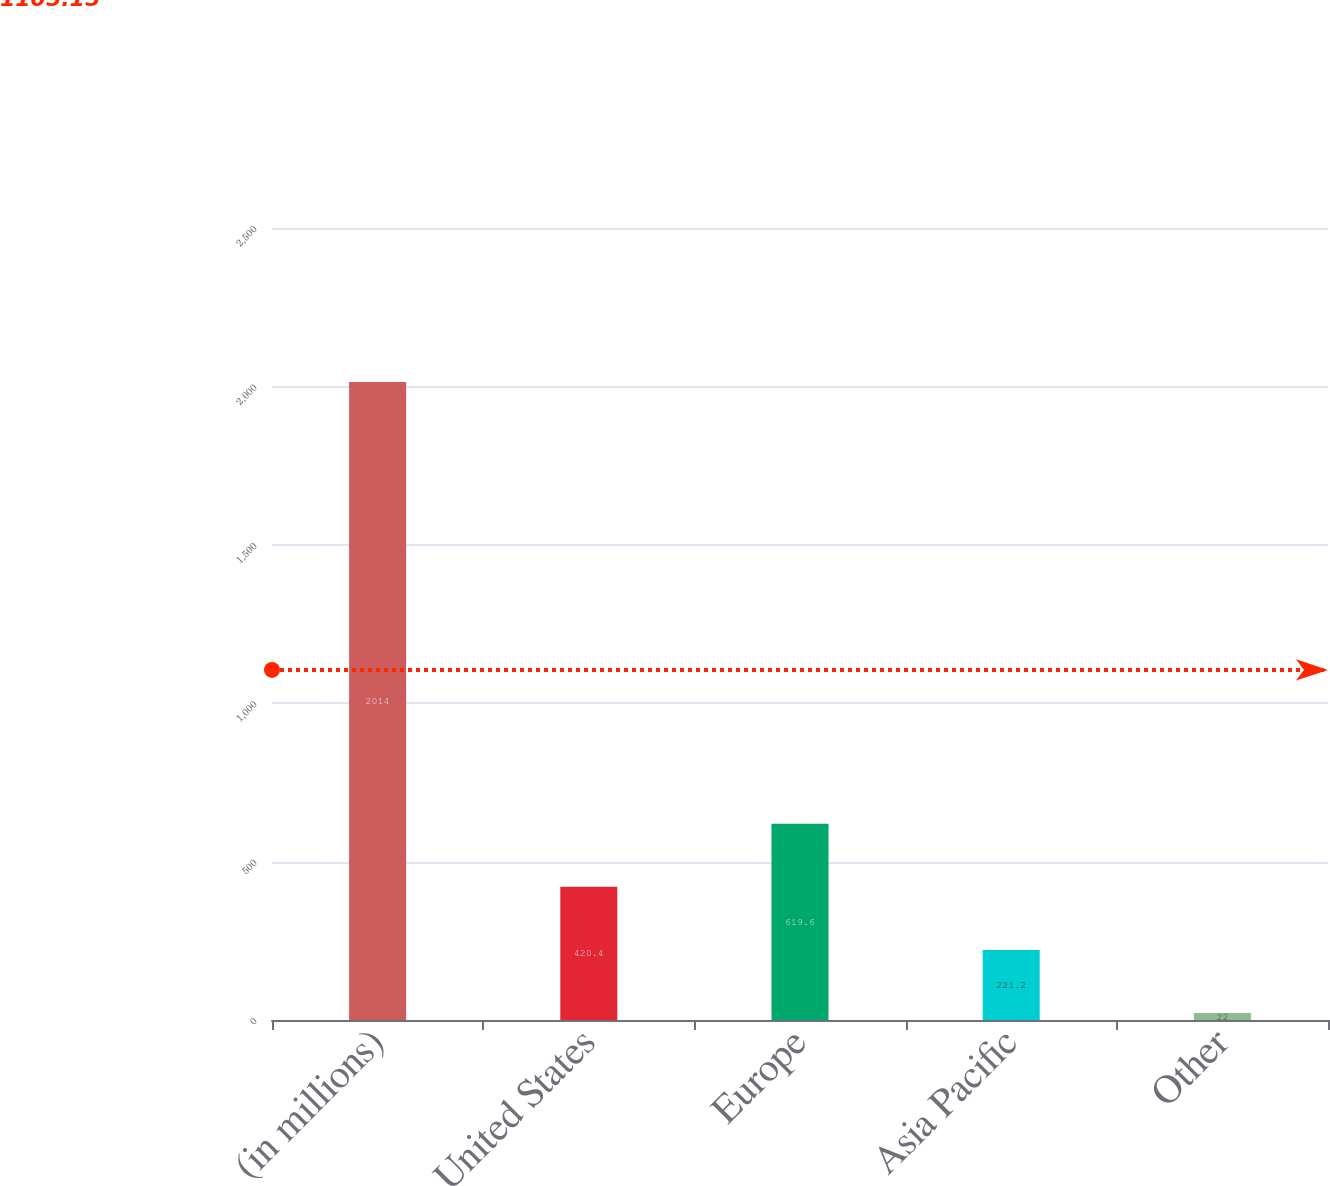Convert chart to OTSL. <chart><loc_0><loc_0><loc_500><loc_500><bar_chart><fcel>(in millions)<fcel>United States<fcel>Europe<fcel>Asia Pacific<fcel>Other<nl><fcel>2014<fcel>420.4<fcel>619.6<fcel>221.2<fcel>22<nl></chart> 